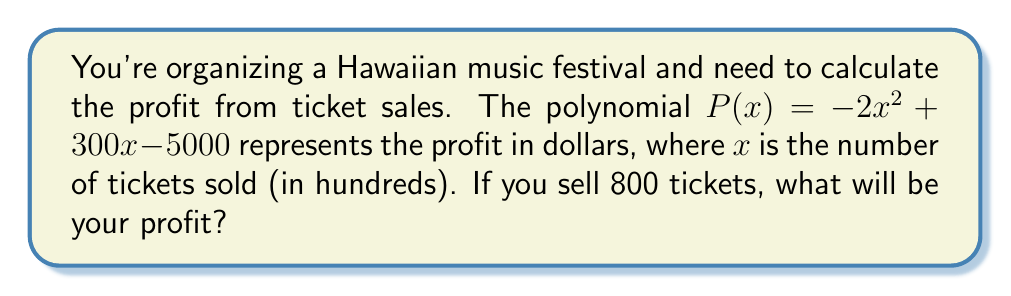What is the answer to this math problem? Let's approach this step-by-step:

1) We're given the profit function: $P(x) = -2x^2 + 300x - 5000$

2) We need to find $P(8)$ because 800 tickets = 8 hundreds of tickets

3) Let's substitute $x = 8$ into the polynomial:

   $P(8) = -2(8)^2 + 300(8) - 5000$

4) Now, let's calculate each term:
   - $-2(8)^2 = -2(64) = -128$
   - $300(8) = 2400$
   - $-5000$ remains as is

5) Adding these terms:

   $P(8) = -128 + 2400 - 5000 = -2728$

6) Therefore, the profit from selling 800 tickets is $-2728$.

Note: The negative profit indicates a loss of $2,728.
Answer: $-$2,728 